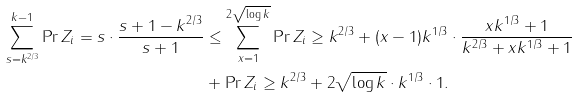<formula> <loc_0><loc_0><loc_500><loc_500>\sum _ { s = k ^ { 2 / 3 } } ^ { k - 1 } \Pr { Z _ { i } = s } \cdot \frac { s + 1 - k ^ { 2 / 3 } } { s + 1 } & \leq \sum _ { x = 1 } ^ { 2 \sqrt { \log k } } \Pr { Z _ { i } \geq k ^ { 2 / 3 } + ( x - 1 ) k ^ { 1 / 3 } } \cdot \frac { x k ^ { 1 / 3 } + 1 } { k ^ { 2 / 3 } + x k ^ { 1 / 3 } + 1 } \\ & + \Pr { Z _ { i } \geq k ^ { 2 / 3 } + 2 \sqrt { \log k } \cdot k ^ { 1 / 3 } } \cdot 1 .</formula> 